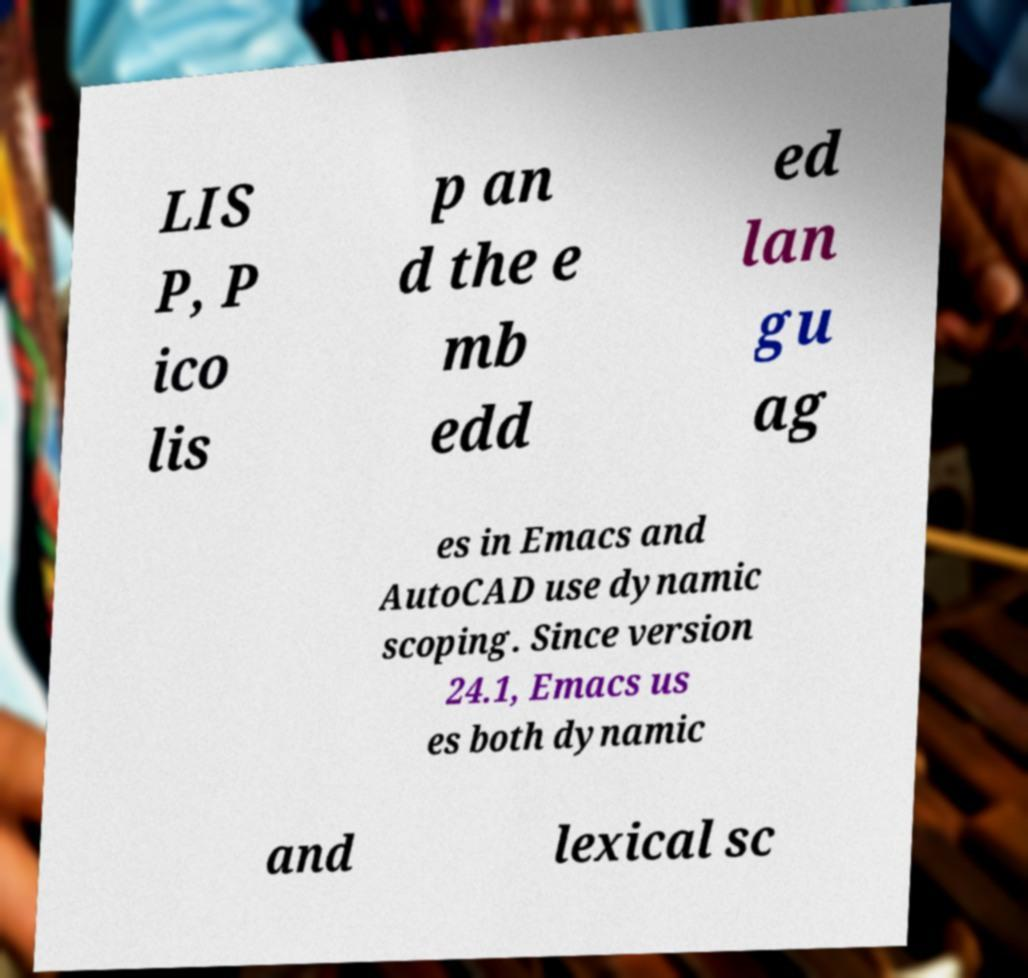Please identify and transcribe the text found in this image. LIS P, P ico lis p an d the e mb edd ed lan gu ag es in Emacs and AutoCAD use dynamic scoping. Since version 24.1, Emacs us es both dynamic and lexical sc 